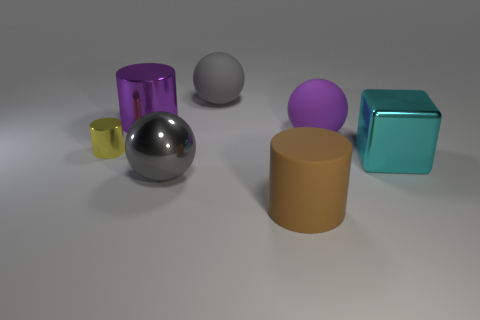Are there any other things that have the same size as the yellow cylinder?
Make the answer very short. No. Is the number of large purple rubber spheres that are right of the big purple matte ball greater than the number of gray spheres to the left of the yellow metallic object?
Provide a succinct answer. No. How many objects are shiny cylinders or large metal blocks?
Your answer should be compact. 3. What number of other objects are there of the same color as the large metallic block?
Provide a succinct answer. 0. What shape is the purple shiny thing that is the same size as the purple matte thing?
Your answer should be very brief. Cylinder. There is a shiny thing on the right side of the large brown matte cylinder; what color is it?
Your answer should be compact. Cyan. How many things are rubber things that are in front of the tiny metal object or big balls that are behind the yellow thing?
Ensure brevity in your answer.  3. Is the purple matte object the same size as the purple metal thing?
Give a very brief answer. Yes. How many blocks are small yellow shiny things or big brown things?
Ensure brevity in your answer.  0. How many cylinders are behind the big brown matte thing and to the right of the yellow object?
Offer a very short reply. 1. 